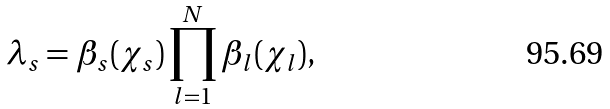<formula> <loc_0><loc_0><loc_500><loc_500>\lambda _ { s } = \beta _ { s } ( \chi _ { s } ) \prod _ { l = 1 } ^ { N } \beta _ { l } ( \chi _ { l } ) ,</formula> 